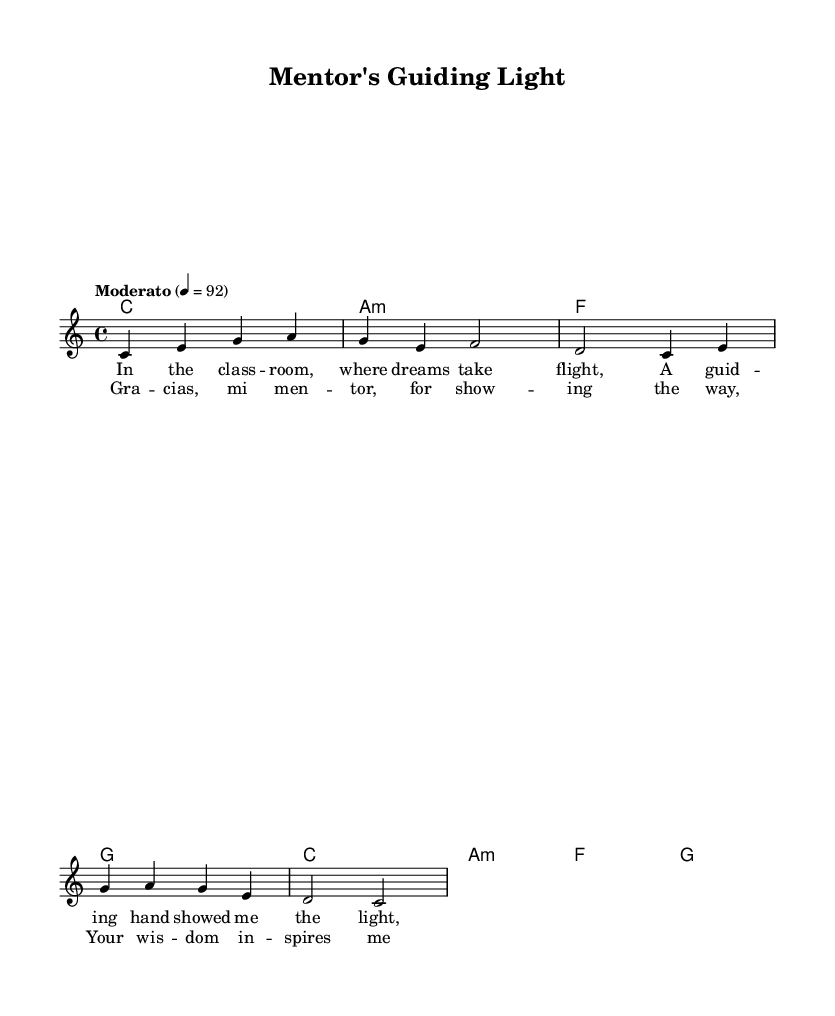What is the key signature of this music? The key signature shown is C major, which has no sharps or flats indicated at the beginning of the staff.
Answer: C major What is the time signature of this music? The time signature is located at the beginning of the score, indicated as 4/4, which means there are four beats in each measure and the quarter note gets one beat.
Answer: 4/4 What is the tempo marking of this piece? The tempo marking is indicated in the score as "Moderato" with a metronome marking of 4 = 92, suggesting a moderate pace to the music.
Answer: Moderato How many harmonies are shown in the score? The harmonies are indicated within the chord section and include four distinct chord types: C, A minor, F, and G. Counting the unique chords, there are four.
Answer: 4 What is the main theme of the lyrics in this piece? The lyrics focus on expressing gratitude towards a mentor for guidance and inspiration in education, evident from phrases like "guiding hand" and "wisdom inspires."
Answer: Gratitude Which type of music is this sheet representative of? This sheet represents a Latin ballad, which is characterized by its emotional themes and often celebrates achievements, as seen in the lyrics and melodic structure.
Answer: Latin ballad 